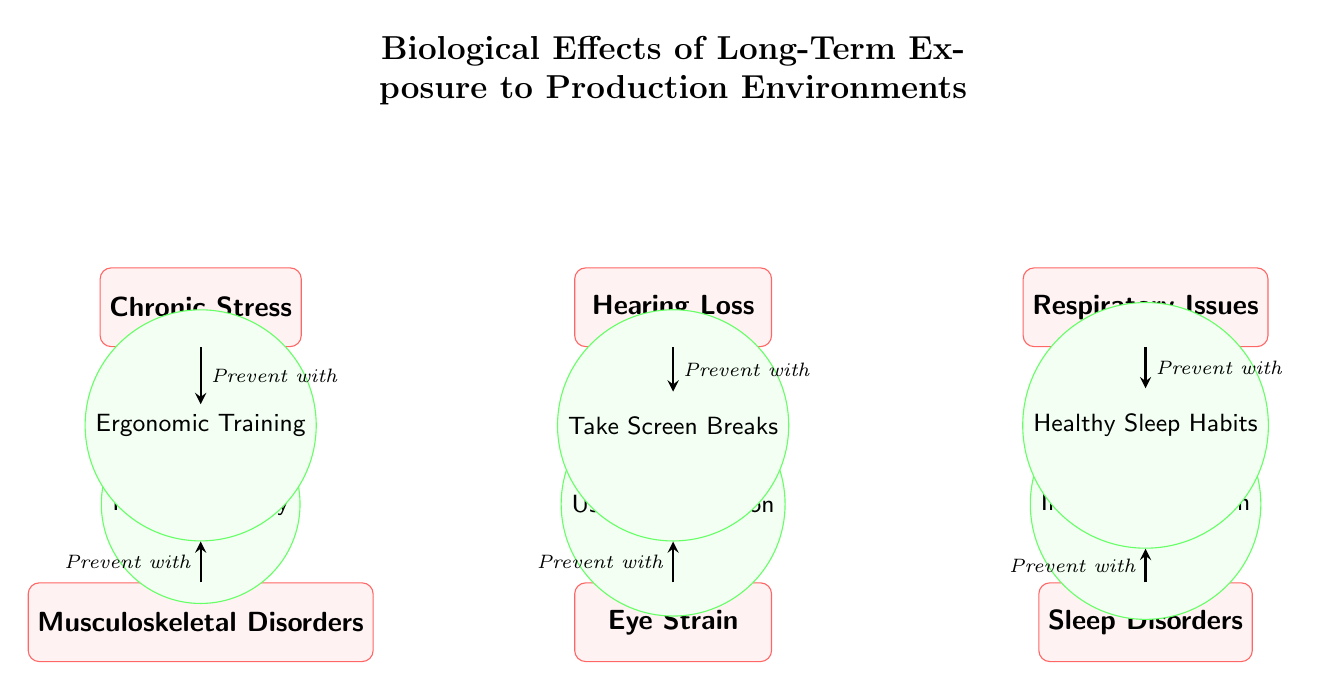What are the three health issues listed on the left side? The left side of the diagram lists Chronic Stress, Musculoskeletal Disorders, and Eye Strain as health issues.
Answer: Chronic Stress, Musculoskeletal Disorders, Eye Strain How many health issues are depicted in total? The diagram displays a total of six health issues, which are Chronic Stress, Hearing Loss, Respiratory Issues, Musculoskeletal Disorders, Eye Strain, and Sleep Disorders.
Answer: 6 What preventative measure is associated with Hearing Loss? The preventative measure linked to Hearing Loss is "Use Ear Protection." This is indicated by the arrow pointing from the Hearing Loss node to the corresponding prevention node.
Answer: Use Ear Protection Which health issue is prevented by regular therapy? Regular Therapy is linked as a preventative measure for Chronic Stress, as seen in the arrow connecting these two nodes in the diagram.
Answer: Chronic Stress What is the connection between Musculoskeletal Disorders and Ergonomic Training? Musculoskeletal Disorders is linked to Ergonomic Training through an arrow that indicates that Ergonomic Training serves as a preventative measure for this specific health issue.
Answer: Preventative Measure How many preventative measures are recommended in the diagram? There are six preventative measures shown in the diagram, which correspond to each health issue listed. These are Regular Therapy, Use Ear Protection, Improve Ventilation, Ergonomic Training, Take Screen Breaks, and Healthy Sleep Habits.
Answer: 6 What type of shape is used to represent health issues in the diagram? Health issues are represented by rectangles with rounded corners, as indicated by the style definitions in the diagram.
Answer: Rectangle Which health issue has an arrow indicating the preventative measure "Improve Ventilation"? The health issue associated with the preventative measure "Improve Ventilation" is Respiratory Issues, as shown by the arrow connecting these two nodes in the diagram.
Answer: Respiratory Issues 